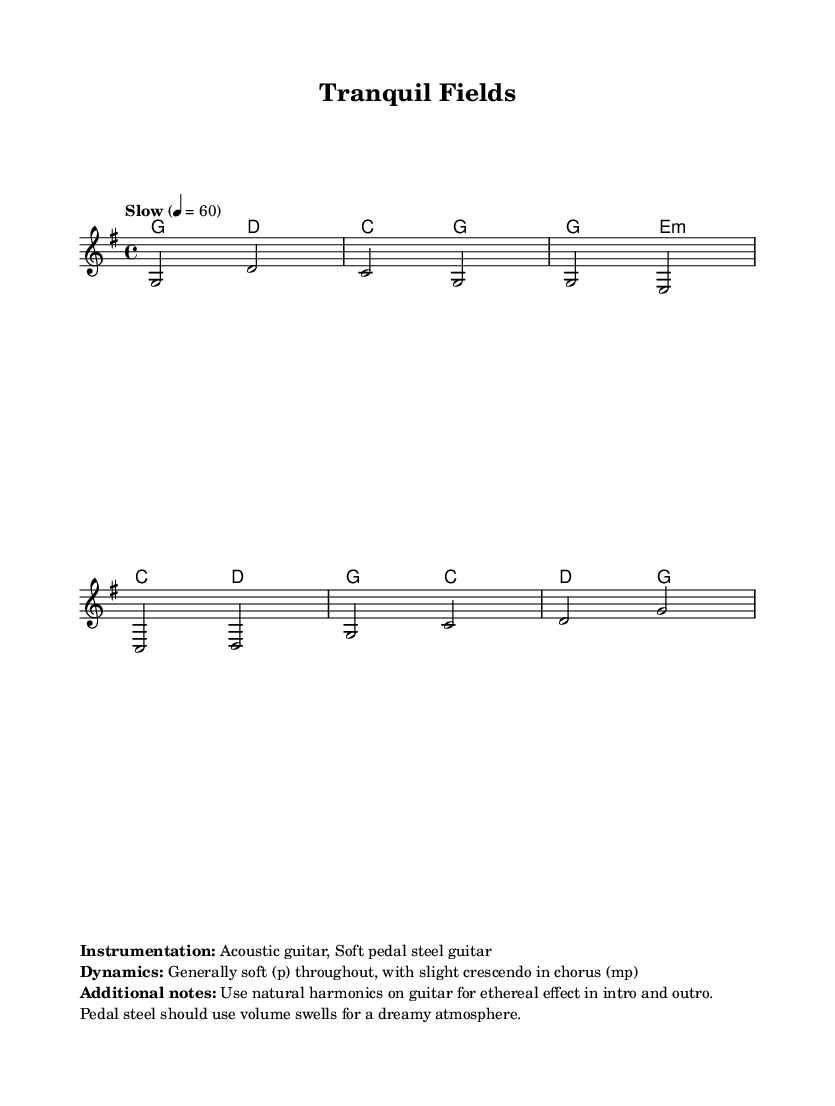What is the key signature of this music? The key signature is G major, which has one sharp (F#). You can identify the key signature at the beginning of the music sheet, marked with the "key" symbol and the letter "G" at the top.
Answer: G major What is the time signature of this music? The time signature is 4/4, meaning there are four beats in each measure and the quarter note gets one beat. This can be found in the beginning of the music sheet next to the key signature.
Answer: 4/4 What is the tempo indicated in the music? The tempo is "Slow" at 60 beats per minute, which indicates how fast the piece should be played. This is specified at the beginning of the music under the tempo markings.
Answer: Slow 4 = 60 What instruments are used in this piece? The instrumentation includes Acoustic guitar and Soft pedal steel guitar, as noted at the bottom of the music sheet in the additional notes. This indicates the types of instruments meant to perform the piece.
Answer: Acoustic guitar, Soft pedal steel guitar How many measures are in the verse section of the music? The verse section consists of two measures. This can be determined by looking at the notation in the verse part of the score where the music notes are organized into measures, and counting them.
Answer: 2 What dynamic marking is indicated for the chorus? The dynamics for the chorus indicate a slight crescendo to mezzo-piano, which is noted in the additional information section at the bottom of the sheet music. This means it should build slightly in volume.
Answer: mp What special technique is suggested for the guitar in the intro? The suggested technique is to use natural harmonics on guitar for an ethereal effect in the introduction. This is specified in the additional notes section, which provides performance instructions.
Answer: Natural harmonics 